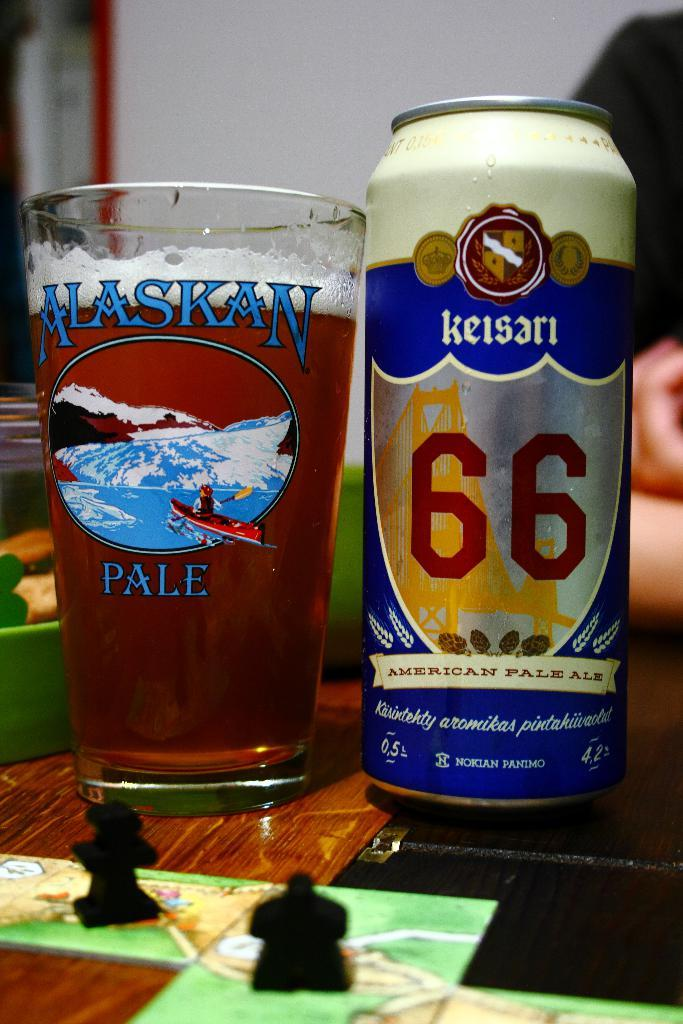<image>
Write a terse but informative summary of the picture. a few cans with one that has 66 on it 